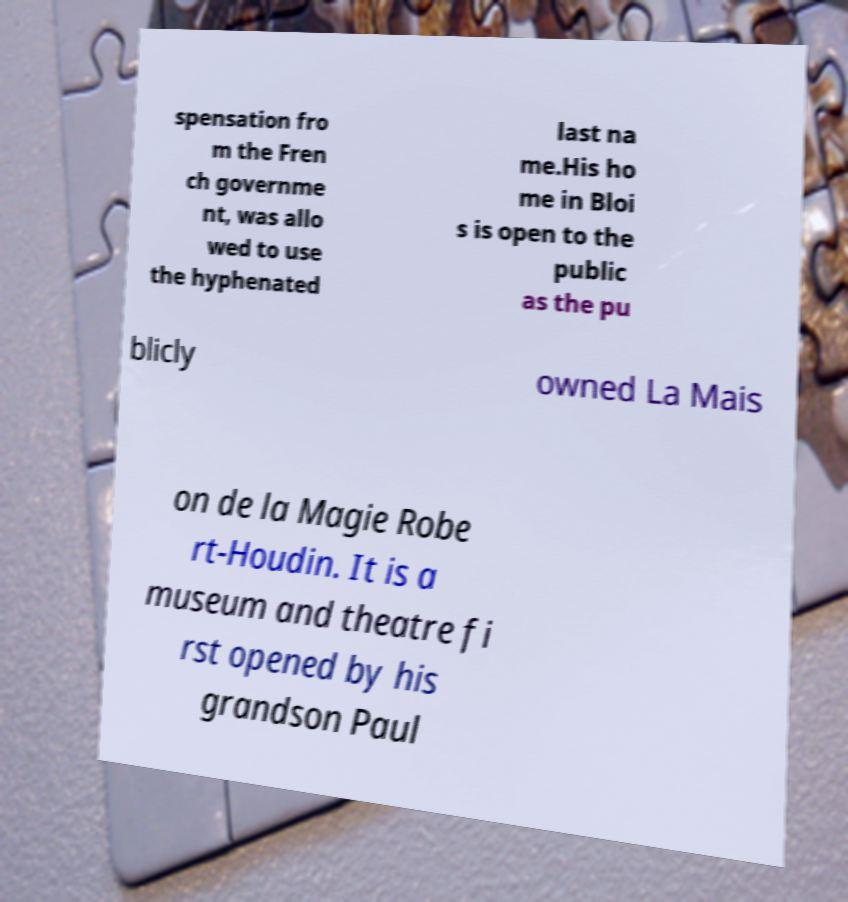Can you read and provide the text displayed in the image?This photo seems to have some interesting text. Can you extract and type it out for me? spensation fro m the Fren ch governme nt, was allo wed to use the hyphenated last na me.His ho me in Bloi s is open to the public as the pu blicly owned La Mais on de la Magie Robe rt-Houdin. It is a museum and theatre fi rst opened by his grandson Paul 